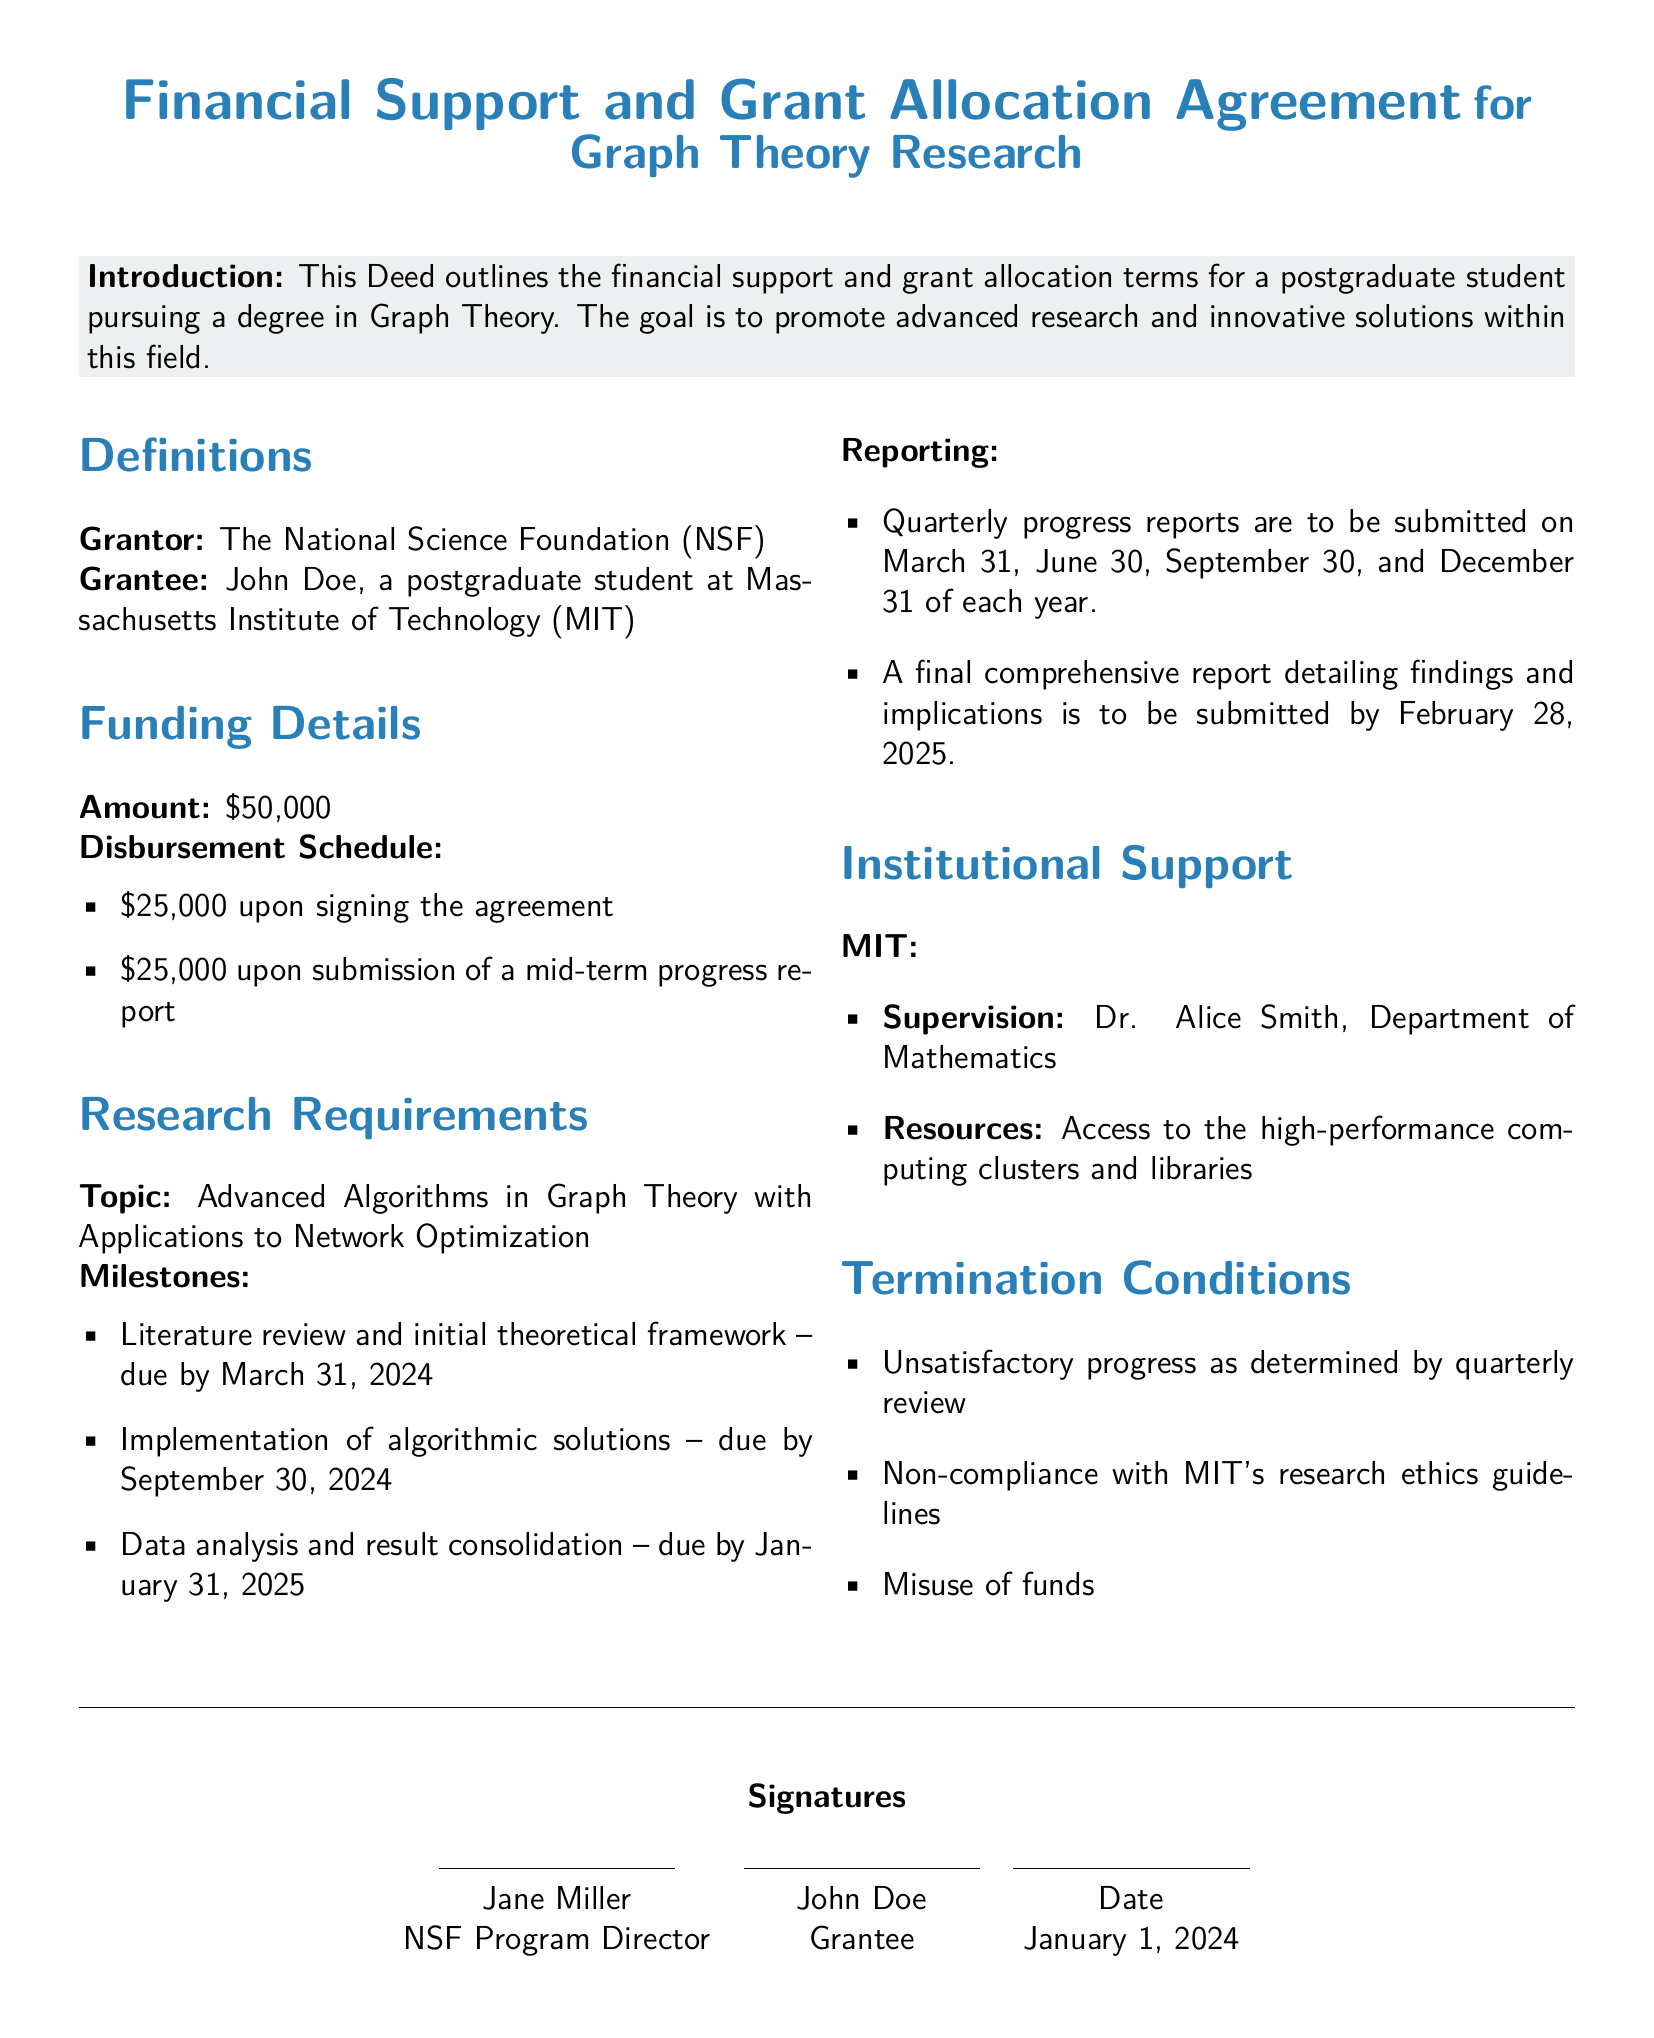What is the total funding amount? The total funding amount is specified at the beginning of the funding details section.
Answer: $50,000 Who is the Grantee? The Grantee's name is mentioned at the start of the document, following the definition section.
Answer: John Doe What is the first milestone due date? The first milestone due date is listed under research requirements as the due date for the literature review.
Answer: March 31, 2024 What is the topic of the research? The topic is clearly defined in the research requirements section.
Answer: Advanced Algorithms in Graph Theory with Applications to Network Optimization Who supervises the Grantee at MIT? The supervisor's name is found under the institutional support section.
Answer: Dr. Alice Smith What are the payment conditions upon signing? The payment conditions upon signing are listed in the disbursement schedule for the grant.
Answer: $25,000 upon signing the agreement What must be submitted by February 28, 2025? The required submission date is noted in the reporting section of the research requirements.
Answer: A final comprehensive report detailing findings and implications What can lead to termination of the agreement? The termination conditions provide specific instances which can lead to termination.
Answer: Unsatisfactory progress as determined by quarterly review What is the date mentioned in the signatures section? The date of signature is stated at the bottom of the document near the signature section.
Answer: January 1, 2024 